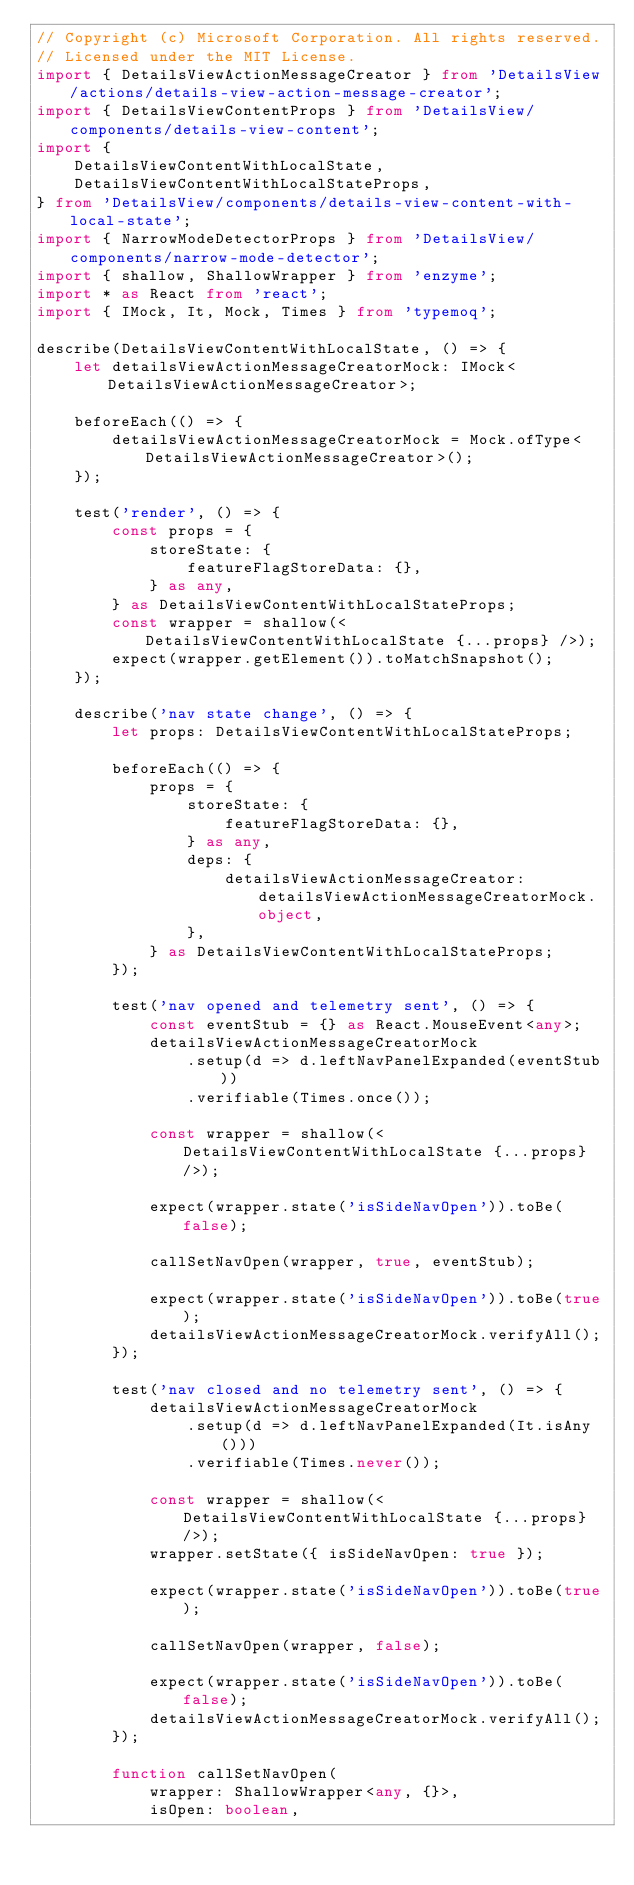<code> <loc_0><loc_0><loc_500><loc_500><_TypeScript_>// Copyright (c) Microsoft Corporation. All rights reserved.
// Licensed under the MIT License.
import { DetailsViewActionMessageCreator } from 'DetailsView/actions/details-view-action-message-creator';
import { DetailsViewContentProps } from 'DetailsView/components/details-view-content';
import {
    DetailsViewContentWithLocalState,
    DetailsViewContentWithLocalStateProps,
} from 'DetailsView/components/details-view-content-with-local-state';
import { NarrowModeDetectorProps } from 'DetailsView/components/narrow-mode-detector';
import { shallow, ShallowWrapper } from 'enzyme';
import * as React from 'react';
import { IMock, It, Mock, Times } from 'typemoq';

describe(DetailsViewContentWithLocalState, () => {
    let detailsViewActionMessageCreatorMock: IMock<DetailsViewActionMessageCreator>;

    beforeEach(() => {
        detailsViewActionMessageCreatorMock = Mock.ofType<DetailsViewActionMessageCreator>();
    });

    test('render', () => {
        const props = {
            storeState: {
                featureFlagStoreData: {},
            } as any,
        } as DetailsViewContentWithLocalStateProps;
        const wrapper = shallow(<DetailsViewContentWithLocalState {...props} />);
        expect(wrapper.getElement()).toMatchSnapshot();
    });

    describe('nav state change', () => {
        let props: DetailsViewContentWithLocalStateProps;

        beforeEach(() => {
            props = {
                storeState: {
                    featureFlagStoreData: {},
                } as any,
                deps: {
                    detailsViewActionMessageCreator: detailsViewActionMessageCreatorMock.object,
                },
            } as DetailsViewContentWithLocalStateProps;
        });

        test('nav opened and telemetry sent', () => {
            const eventStub = {} as React.MouseEvent<any>;
            detailsViewActionMessageCreatorMock
                .setup(d => d.leftNavPanelExpanded(eventStub))
                .verifiable(Times.once());

            const wrapper = shallow(<DetailsViewContentWithLocalState {...props} />);

            expect(wrapper.state('isSideNavOpen')).toBe(false);

            callSetNavOpen(wrapper, true, eventStub);

            expect(wrapper.state('isSideNavOpen')).toBe(true);
            detailsViewActionMessageCreatorMock.verifyAll();
        });

        test('nav closed and no telemetry sent', () => {
            detailsViewActionMessageCreatorMock
                .setup(d => d.leftNavPanelExpanded(It.isAny()))
                .verifiable(Times.never());

            const wrapper = shallow(<DetailsViewContentWithLocalState {...props} />);
            wrapper.setState({ isSideNavOpen: true });

            expect(wrapper.state('isSideNavOpen')).toBe(true);

            callSetNavOpen(wrapper, false);

            expect(wrapper.state('isSideNavOpen')).toBe(false);
            detailsViewActionMessageCreatorMock.verifyAll();
        });

        function callSetNavOpen(
            wrapper: ShallowWrapper<any, {}>,
            isOpen: boolean,</code> 